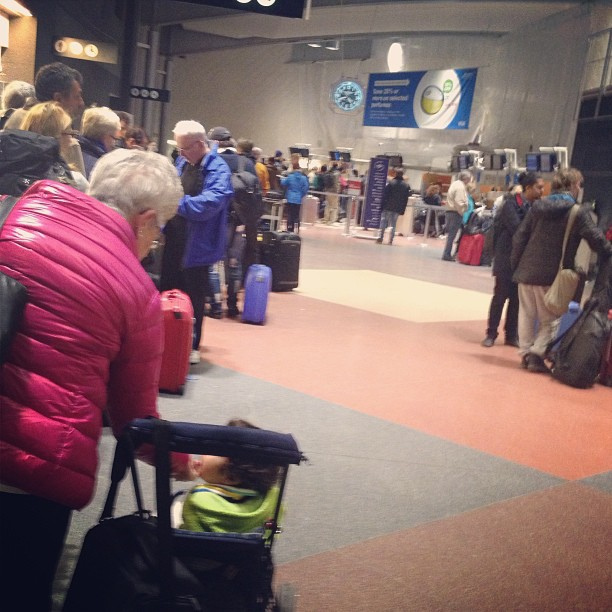<image>Who has the most luggage? It is ambiguous who has the most luggage, though some answers suggest it could be the woman. Who has the most luggage? It is not clear who has the most luggage. It could be any of the women in the image. 